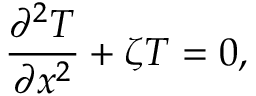<formula> <loc_0><loc_0><loc_500><loc_500>\frac { { { \partial ^ { 2 } } T } } { { \partial { x ^ { 2 } } } } + \zeta T = 0 ,</formula> 